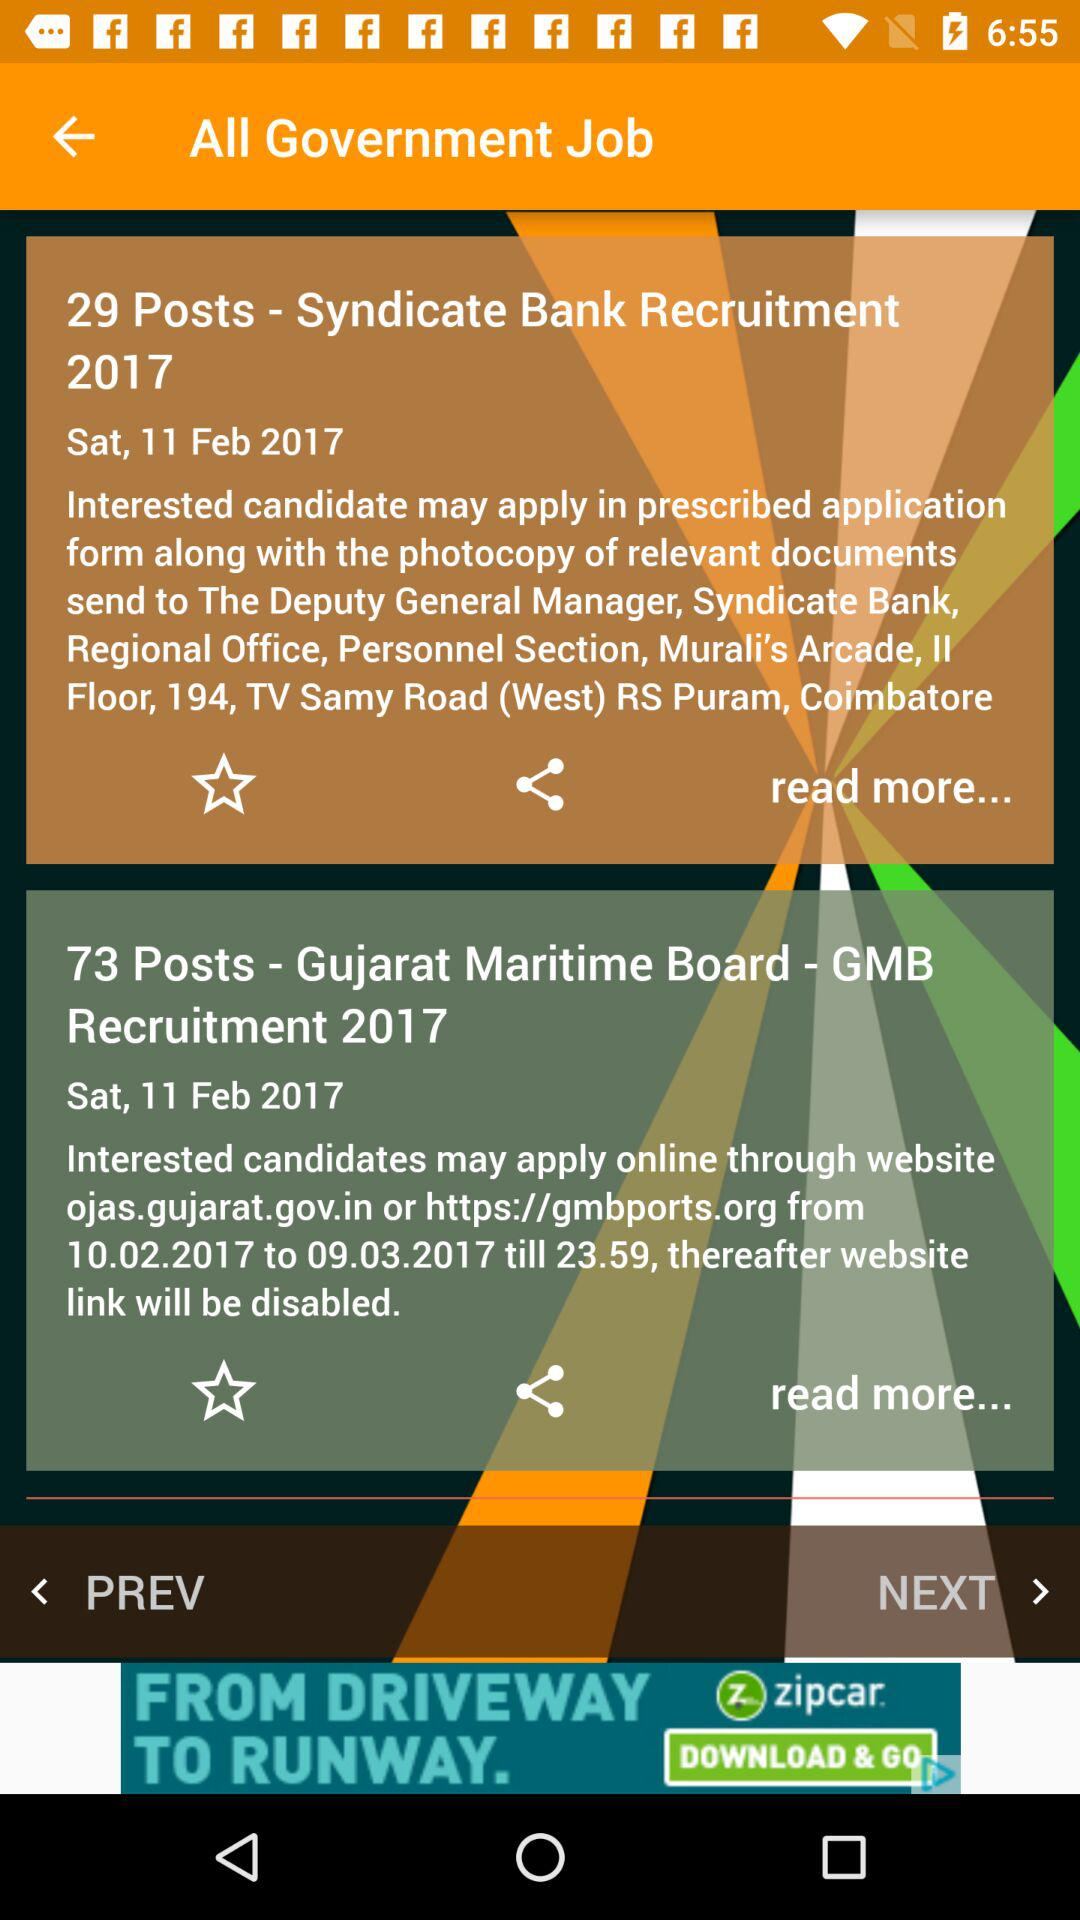How many posts are vacant in the "Gujarat Maritime Board"? There are 73 posts vacant in the "Gujarat Maritime Board". 